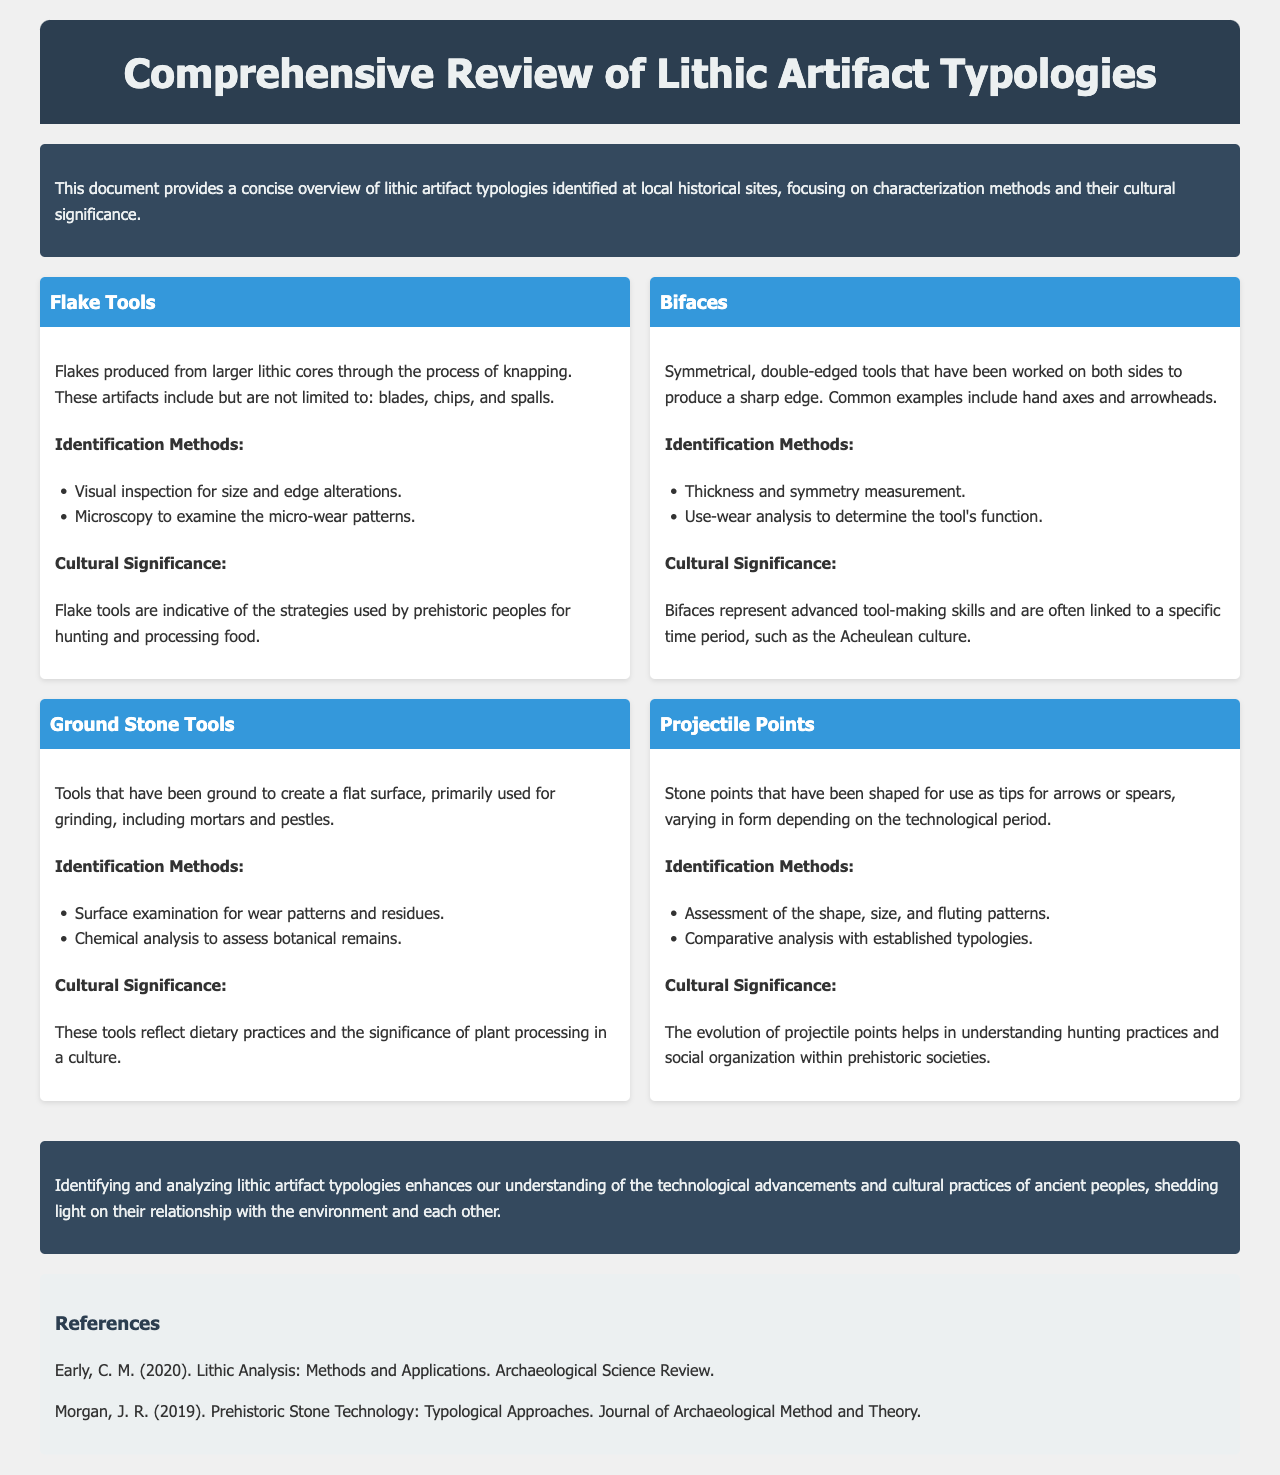What are flake tools? Flake tools are flakes produced from larger lithic cores through the process of knapping, including blades, chips, and spalls.
Answer: Flake tools What were bifaces used for? Bifaces are symmetrical, double-edged tools that produce a sharp edge, commonly used as hand axes and arrowheads.
Answer: Hand axes and arrowheads What identification method is used for ground stone tools? Surface examination for wear patterns and residues is one method used for identifying ground stone tools.
Answer: Surface examination What cultural significance do projectile points hold? The evolution of projectile points helps in understanding hunting practices and social organization within prehistoric societies.
Answer: Understanding hunting practices What year was the reference by Early published? The reference by Early was published in 2020.
Answer: 2020 What archaeological concept do bifaces represent? Bifaces represent advanced tool-making skills linked to specific time periods, such as the Acheulean culture.
Answer: Advanced tool-making skills How are flake tools identified? Flake tools are identified through visual inspection for size and edge alterations and microscopy to examine micro-wear patterns.
Answer: Visual inspection and microscopy What type of report is this document? This document is a comprehensive review of lithic artifact typologies.
Answer: Comprehensive review 